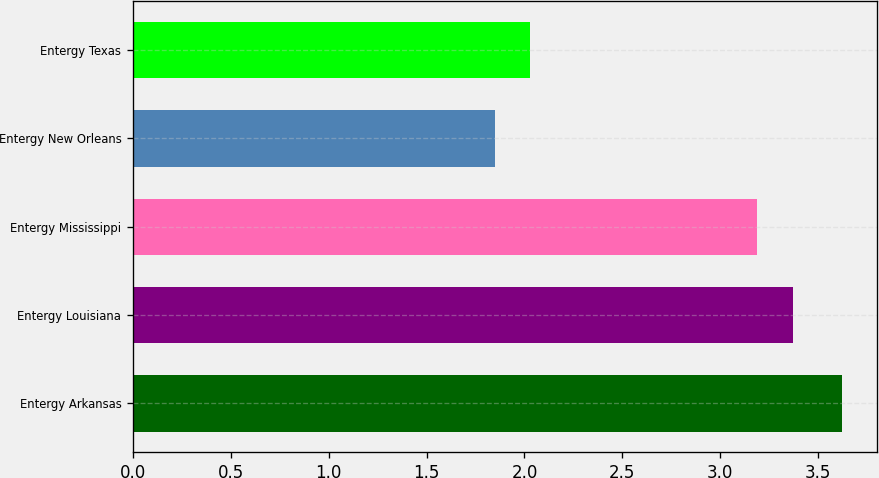<chart> <loc_0><loc_0><loc_500><loc_500><bar_chart><fcel>Entergy Arkansas<fcel>Entergy Louisiana<fcel>Entergy Mississippi<fcel>Entergy New Orleans<fcel>Entergy Texas<nl><fcel>3.62<fcel>3.37<fcel>3.19<fcel>1.85<fcel>2.03<nl></chart> 